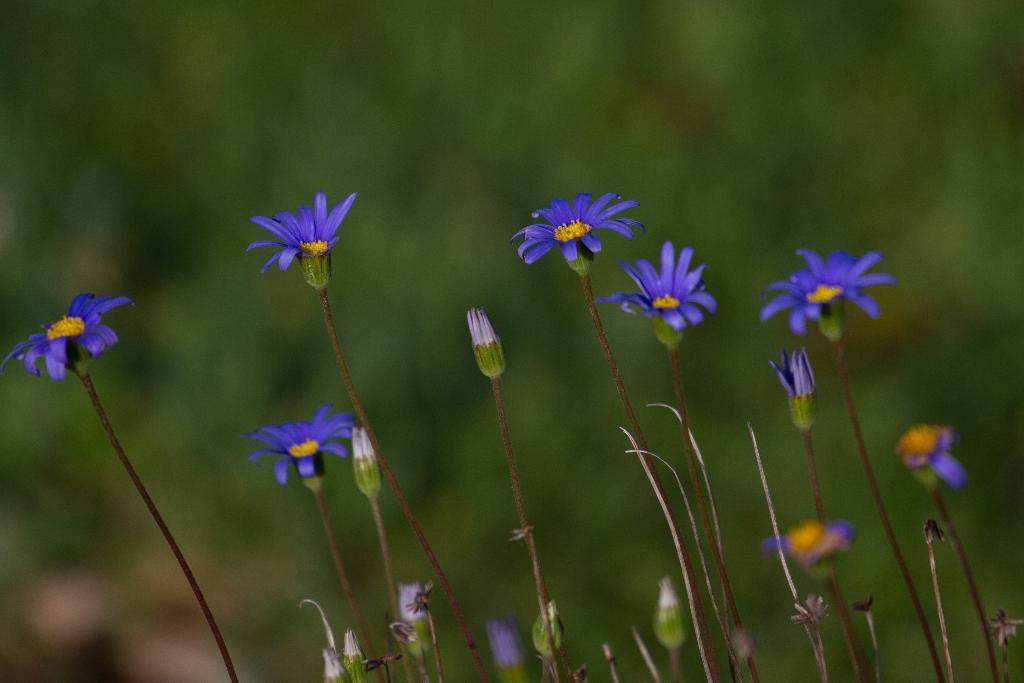What type of plants can be seen in the image? There are flowers in the image. What stage of growth are the flowers in the image? There are buds on the stems in the image. Can you describe the background of the image? The background of the image is blurry. What type of error can be seen in the image? There is no error present in the image; it features flowers with buds on the stems. How long does it take for the flowers to bloom in the image? The image does not provide information about the time it takes for the flowers to bloom; it only shows the flowers and buds on the stems. 